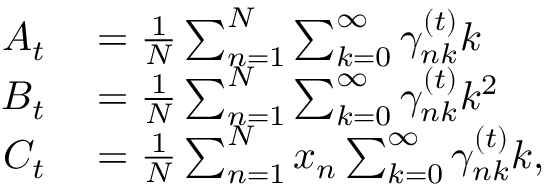<formula> <loc_0><loc_0><loc_500><loc_500>\begin{array} { r l } { A _ { t } } & = \frac { 1 } { N } \sum _ { n = 1 } ^ { N } \sum _ { k = 0 } ^ { \infty } \gamma _ { n k } ^ { ( t ) } k } \\ { B _ { t } } & = \frac { 1 } { N } \sum _ { n = 1 } ^ { N } \sum _ { k = 0 } ^ { \infty } \gamma _ { n k } ^ { ( t ) } k ^ { 2 } } \\ { C _ { t } } & = \frac { 1 } { N } \sum _ { n = 1 } ^ { N } x _ { n } \sum _ { k = 0 } ^ { \infty } \gamma _ { n k } ^ { ( t ) } k , } \end{array}</formula> 